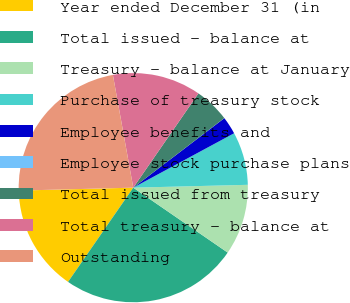Convert chart to OTSL. <chart><loc_0><loc_0><loc_500><loc_500><pie_chart><fcel>Year ended December 31 (in<fcel>Total issued - balance at<fcel>Treasury - balance at January<fcel>Purchase of treasury stock<fcel>Employee benefits and<fcel>Employee stock purchase plans<fcel>Total issued from treasury<fcel>Total treasury - balance at<fcel>Outstanding<nl><fcel>14.96%<fcel>25.05%<fcel>9.98%<fcel>7.48%<fcel>2.5%<fcel>0.01%<fcel>4.99%<fcel>12.47%<fcel>22.56%<nl></chart> 